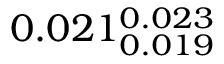<formula> <loc_0><loc_0><loc_500><loc_500>0 . 0 2 1 _ { 0 . 0 1 9 } ^ { 0 . 0 2 3 }</formula> 